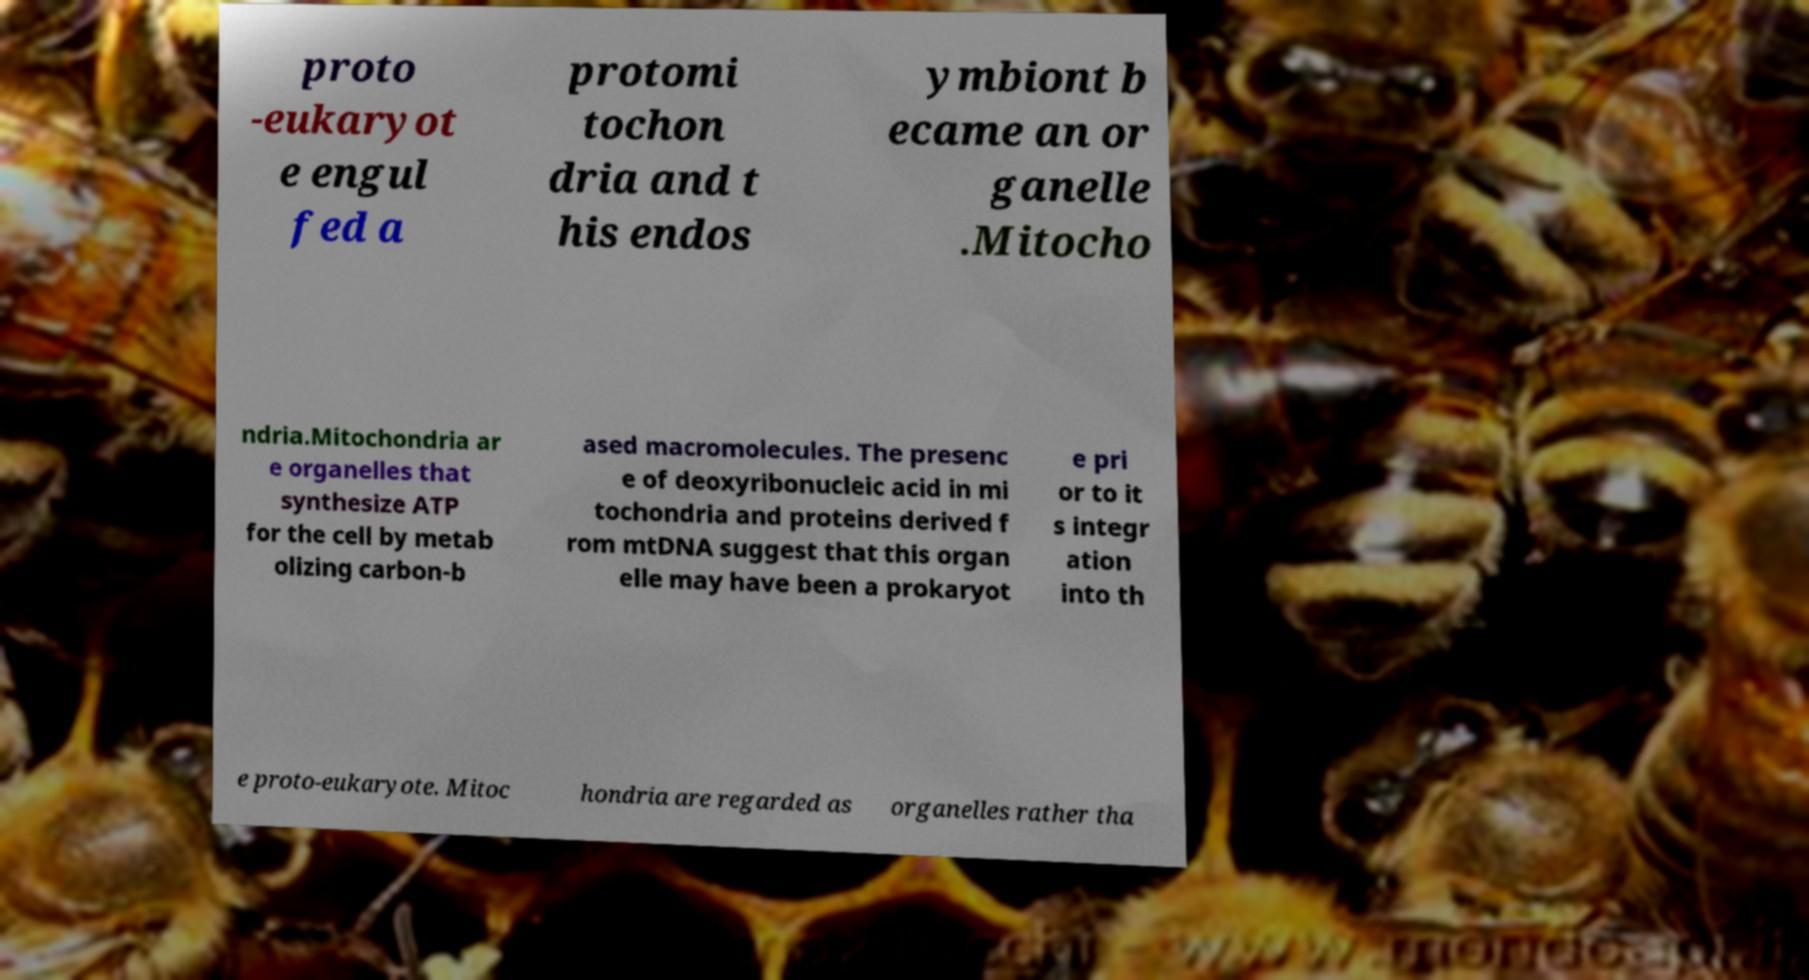Please identify and transcribe the text found in this image. proto -eukaryot e engul fed a protomi tochon dria and t his endos ymbiont b ecame an or ganelle .Mitocho ndria.Mitochondria ar e organelles that synthesize ATP for the cell by metab olizing carbon-b ased macromolecules. The presenc e of deoxyribonucleic acid in mi tochondria and proteins derived f rom mtDNA suggest that this organ elle may have been a prokaryot e pri or to it s integr ation into th e proto-eukaryote. Mitoc hondria are regarded as organelles rather tha 